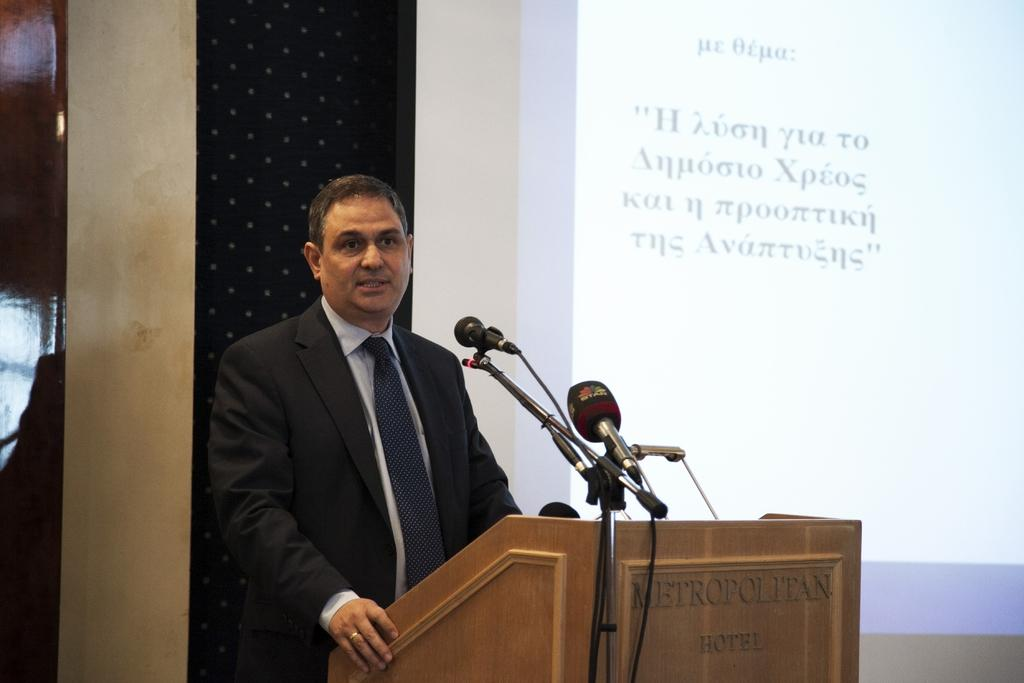What is the man near in the image? The man is standing near the podium. What is used for amplifying sound near the podium? There are microphones near the podium. What is used for displaying visuals in the image? There is a presentation screen in the image. What can be seen in the background of the image? There is a wall and a door in the background of the image. What type of record can be seen spinning on the wall in the image? There is no record present in the image; it only features a man near the podium, microphones, a presentation screen, a wall, and a door. 